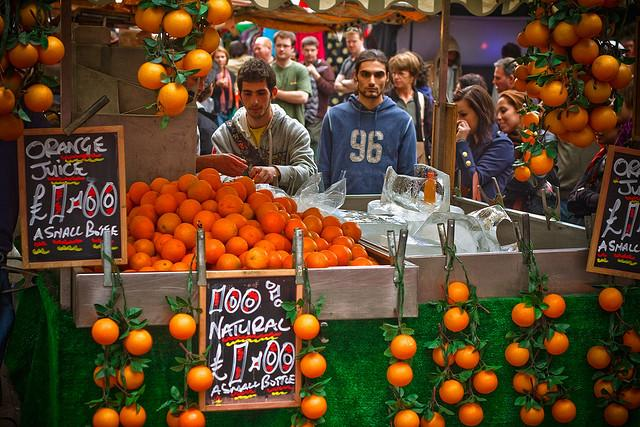What are they waiting in line for? Please explain your reasoning. buy juice. (b) they are waiting in line to pick the oranges they would like to take home. 